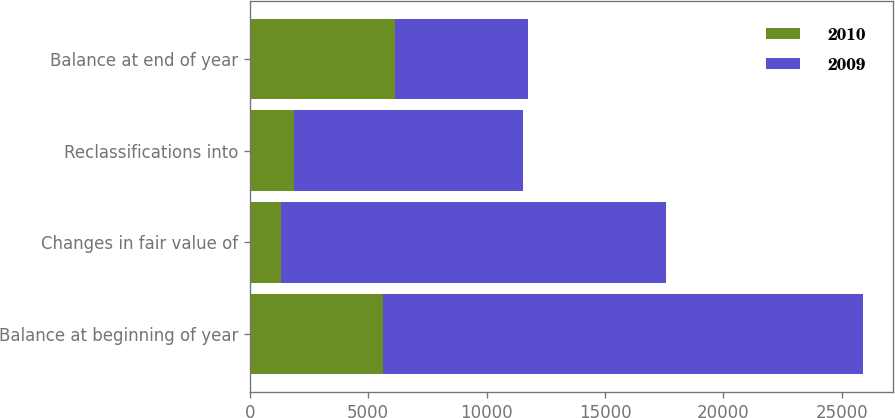Convert chart. <chart><loc_0><loc_0><loc_500><loc_500><stacked_bar_chart><ecel><fcel>Balance at beginning of year<fcel>Changes in fair value of<fcel>Reclassifications into<fcel>Balance at end of year<nl><fcel>2010<fcel>5609<fcel>1339<fcel>1863<fcel>6133<nl><fcel>2009<fcel>20263<fcel>16215<fcel>9657<fcel>5609<nl></chart> 